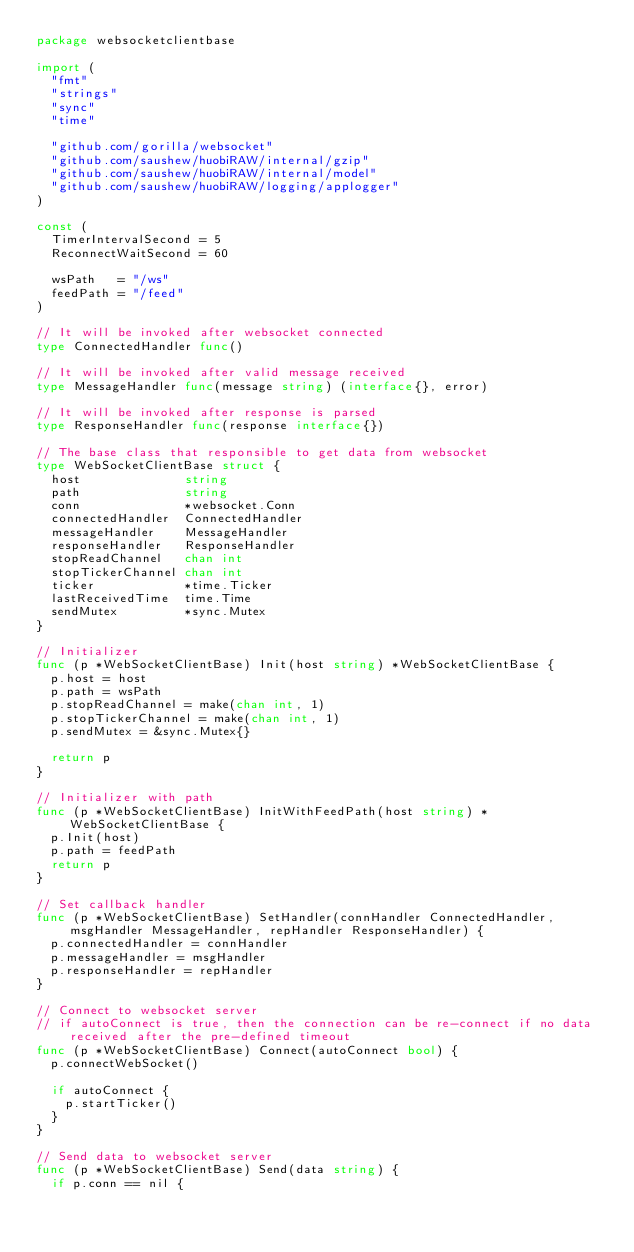<code> <loc_0><loc_0><loc_500><loc_500><_Go_>package websocketclientbase

import (
	"fmt"
	"strings"
	"sync"
	"time"

	"github.com/gorilla/websocket"
	"github.com/saushew/huobiRAW/internal/gzip"
	"github.com/saushew/huobiRAW/internal/model"
	"github.com/saushew/huobiRAW/logging/applogger"
)

const (
	TimerIntervalSecond = 5
	ReconnectWaitSecond = 60

	wsPath   = "/ws"
	feedPath = "/feed"
)

// It will be invoked after websocket connected
type ConnectedHandler func()

// It will be invoked after valid message received
type MessageHandler func(message string) (interface{}, error)

// It will be invoked after response is parsed
type ResponseHandler func(response interface{})

// The base class that responsible to get data from websocket
type WebSocketClientBase struct {
	host              string
	path              string
	conn              *websocket.Conn
	connectedHandler  ConnectedHandler
	messageHandler    MessageHandler
	responseHandler   ResponseHandler
	stopReadChannel   chan int
	stopTickerChannel chan int
	ticker            *time.Ticker
	lastReceivedTime  time.Time
	sendMutex         *sync.Mutex
}

// Initializer
func (p *WebSocketClientBase) Init(host string) *WebSocketClientBase {
	p.host = host
	p.path = wsPath
	p.stopReadChannel = make(chan int, 1)
	p.stopTickerChannel = make(chan int, 1)
	p.sendMutex = &sync.Mutex{}

	return p
}

// Initializer with path
func (p *WebSocketClientBase) InitWithFeedPath(host string) *WebSocketClientBase {
	p.Init(host)
	p.path = feedPath
	return p
}

// Set callback handler
func (p *WebSocketClientBase) SetHandler(connHandler ConnectedHandler, msgHandler MessageHandler, repHandler ResponseHandler) {
	p.connectedHandler = connHandler
	p.messageHandler = msgHandler
	p.responseHandler = repHandler
}

// Connect to websocket server
// if autoConnect is true, then the connection can be re-connect if no data received after the pre-defined timeout
func (p *WebSocketClientBase) Connect(autoConnect bool) {
	p.connectWebSocket()

	if autoConnect {
		p.startTicker()
	}
}

// Send data to websocket server
func (p *WebSocketClientBase) Send(data string) {
	if p.conn == nil {</code> 